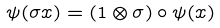<formula> <loc_0><loc_0><loc_500><loc_500>\psi ( \sigma x ) = ( 1 \otimes \sigma ) \circ \psi ( x )</formula> 